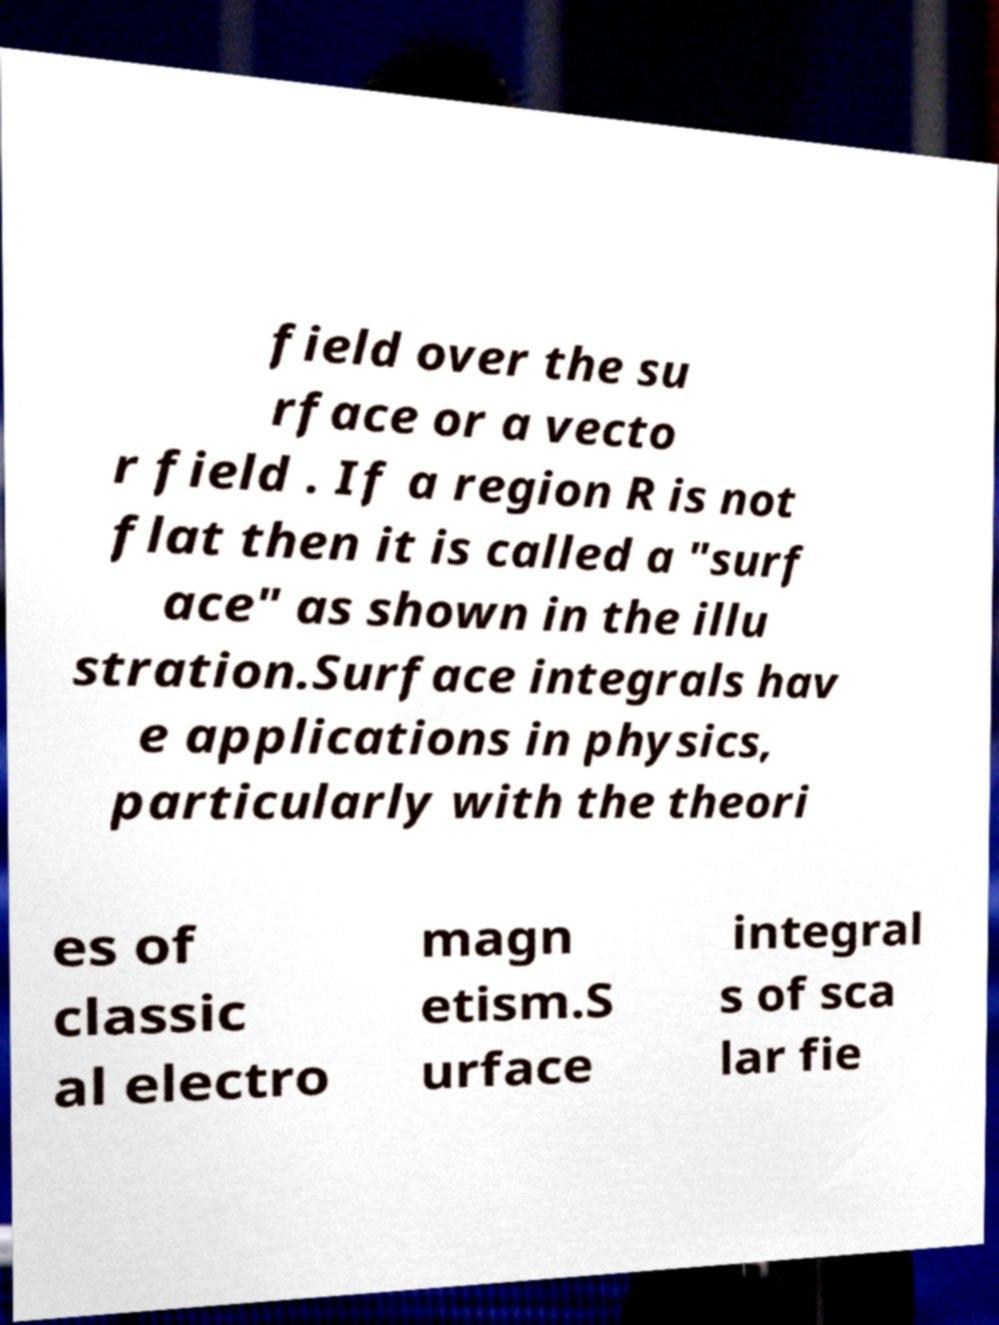Can you accurately transcribe the text from the provided image for me? field over the su rface or a vecto r field . If a region R is not flat then it is called a "surf ace" as shown in the illu stration.Surface integrals hav e applications in physics, particularly with the theori es of classic al electro magn etism.S urface integral s of sca lar fie 